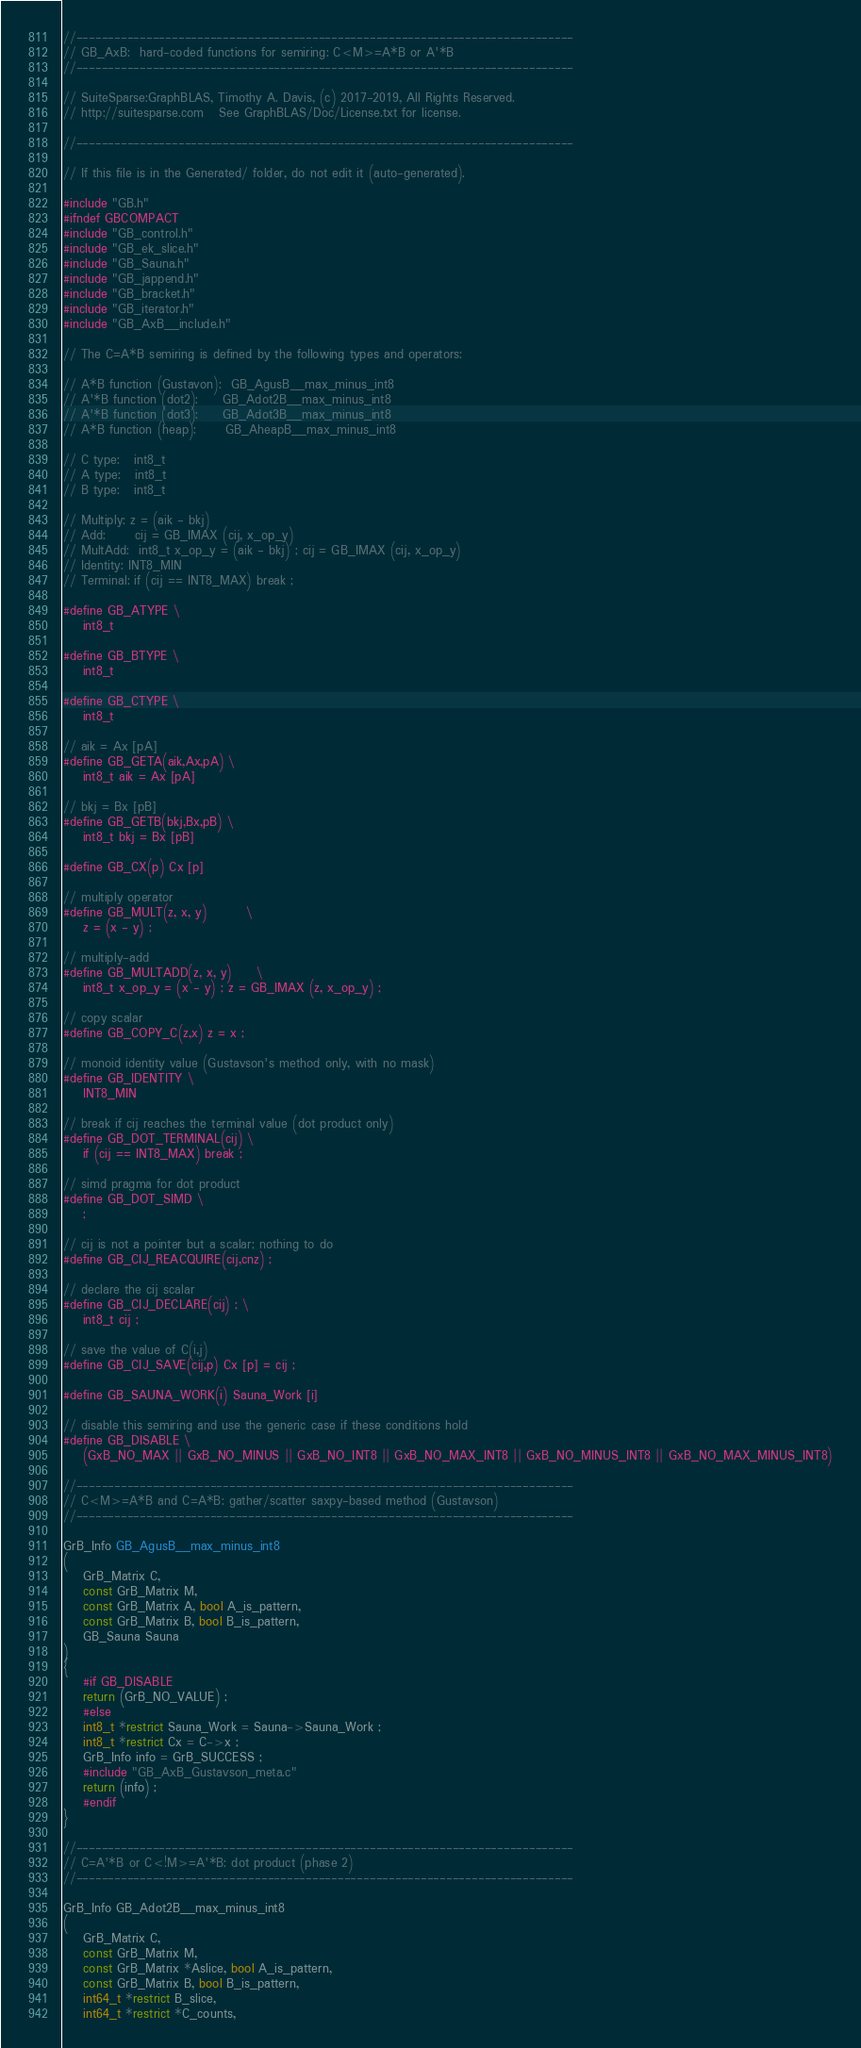Convert code to text. <code><loc_0><loc_0><loc_500><loc_500><_C_>

//------------------------------------------------------------------------------
// GB_AxB:  hard-coded functions for semiring: C<M>=A*B or A'*B
//------------------------------------------------------------------------------

// SuiteSparse:GraphBLAS, Timothy A. Davis, (c) 2017-2019, All Rights Reserved.
// http://suitesparse.com   See GraphBLAS/Doc/License.txt for license.

//------------------------------------------------------------------------------

// If this file is in the Generated/ folder, do not edit it (auto-generated).

#include "GB.h"
#ifndef GBCOMPACT
#include "GB_control.h"
#include "GB_ek_slice.h"
#include "GB_Sauna.h"
#include "GB_jappend.h"
#include "GB_bracket.h"
#include "GB_iterator.h"
#include "GB_AxB__include.h"

// The C=A*B semiring is defined by the following types and operators:

// A*B function (Gustavon):  GB_AgusB__max_minus_int8
// A'*B function (dot2):     GB_Adot2B__max_minus_int8
// A'*B function (dot3):     GB_Adot3B__max_minus_int8
// A*B function (heap):      GB_AheapB__max_minus_int8

// C type:   int8_t
// A type:   int8_t
// B type:   int8_t

// Multiply: z = (aik - bkj)
// Add:      cij = GB_IMAX (cij, x_op_y)
// MultAdd:  int8_t x_op_y = (aik - bkj) ; cij = GB_IMAX (cij, x_op_y)
// Identity: INT8_MIN
// Terminal: if (cij == INT8_MAX) break ;

#define GB_ATYPE \
    int8_t

#define GB_BTYPE \
    int8_t

#define GB_CTYPE \
    int8_t

// aik = Ax [pA]
#define GB_GETA(aik,Ax,pA) \
    int8_t aik = Ax [pA]

// bkj = Bx [pB]
#define GB_GETB(bkj,Bx,pB) \
    int8_t bkj = Bx [pB]

#define GB_CX(p) Cx [p]

// multiply operator
#define GB_MULT(z, x, y)        \
    z = (x - y) ;

// multiply-add
#define GB_MULTADD(z, x, y)     \
    int8_t x_op_y = (x - y) ; z = GB_IMAX (z, x_op_y) ;

// copy scalar
#define GB_COPY_C(z,x) z = x ;

// monoid identity value (Gustavson's method only, with no mask)
#define GB_IDENTITY \
    INT8_MIN

// break if cij reaches the terminal value (dot product only)
#define GB_DOT_TERMINAL(cij) \
    if (cij == INT8_MAX) break ;

// simd pragma for dot product
#define GB_DOT_SIMD \
    ;

// cij is not a pointer but a scalar; nothing to do
#define GB_CIJ_REACQUIRE(cij,cnz) ;

// declare the cij scalar
#define GB_CIJ_DECLARE(cij) ; \
    int8_t cij ;

// save the value of C(i,j)
#define GB_CIJ_SAVE(cij,p) Cx [p] = cij ;

#define GB_SAUNA_WORK(i) Sauna_Work [i]

// disable this semiring and use the generic case if these conditions hold
#define GB_DISABLE \
    (GxB_NO_MAX || GxB_NO_MINUS || GxB_NO_INT8 || GxB_NO_MAX_INT8 || GxB_NO_MINUS_INT8 || GxB_NO_MAX_MINUS_INT8)

//------------------------------------------------------------------------------
// C<M>=A*B and C=A*B: gather/scatter saxpy-based method (Gustavson)
//------------------------------------------------------------------------------

GrB_Info GB_AgusB__max_minus_int8
(
    GrB_Matrix C,
    const GrB_Matrix M,
    const GrB_Matrix A, bool A_is_pattern,
    const GrB_Matrix B, bool B_is_pattern,
    GB_Sauna Sauna
)
{ 
    #if GB_DISABLE
    return (GrB_NO_VALUE) ;
    #else
    int8_t *restrict Sauna_Work = Sauna->Sauna_Work ;
    int8_t *restrict Cx = C->x ;
    GrB_Info info = GrB_SUCCESS ;
    #include "GB_AxB_Gustavson_meta.c"
    return (info) ;
    #endif
}

//------------------------------------------------------------------------------
// C=A'*B or C<!M>=A'*B: dot product (phase 2)
//------------------------------------------------------------------------------

GrB_Info GB_Adot2B__max_minus_int8
(
    GrB_Matrix C,
    const GrB_Matrix M,
    const GrB_Matrix *Aslice, bool A_is_pattern,
    const GrB_Matrix B, bool B_is_pattern,
    int64_t *restrict B_slice,
    int64_t *restrict *C_counts,</code> 